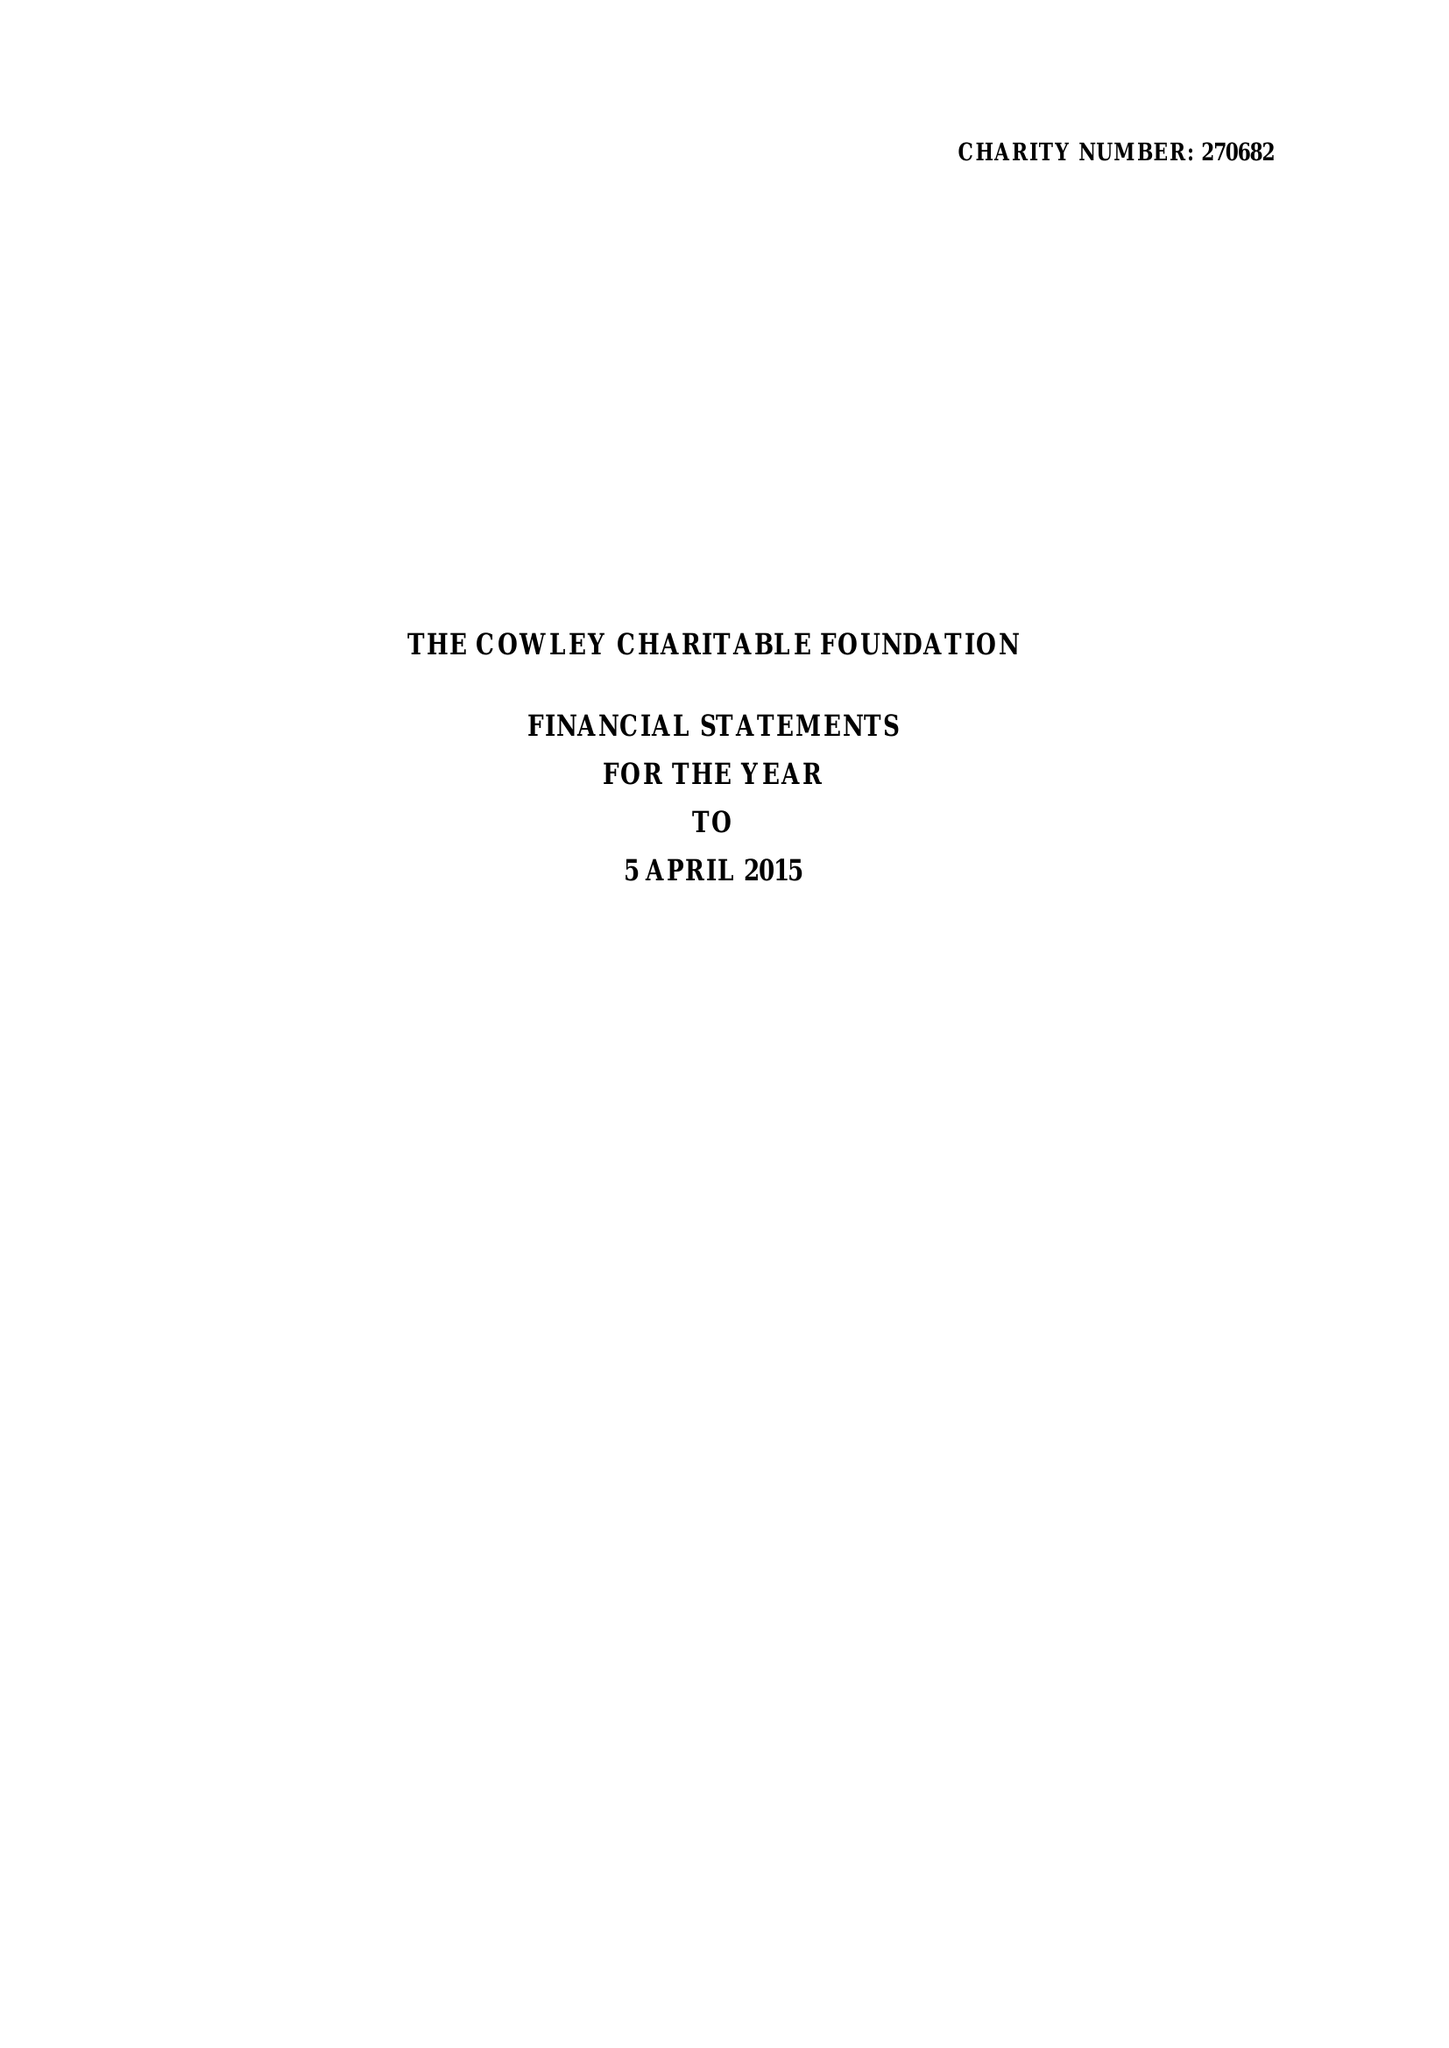What is the value for the address__postcode?
Answer the question using a single word or phrase. SW1W 0BD 